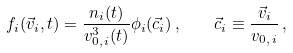<formula> <loc_0><loc_0><loc_500><loc_500>f _ { i } ( \vec { v } _ { i } , t ) = \frac { n _ { i } ( t ) } { v _ { 0 , \, i } ^ { 3 } ( t ) } \phi _ { i } ( \vec { c } _ { i } ) \, , \quad \vec { c } _ { i } \equiv \frac { \vec { v } _ { i } } { v _ { 0 , \, i } } \, ,</formula> 